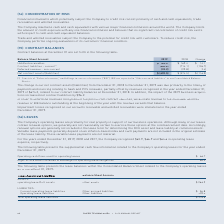According to Roper Technologies's financial document, How does the Company determine revenues recognized in the period from contract liabilities? we allocate revenue to the individual deferred revenue or BIE balance outstanding at the beginning of the year until the revenue exceeds that balance. The document states: "cognized in the period from contract liabilities, we allocate revenue to the individual deferred revenue or BIE balance outstanding at the beginning o..." Also, What were immaterial on the Company’s accounts receivable and unbilled receivables?  According to the financial document, Impairment losses. The relevant text states: "Impairment losses recognized on our accounts receivable and unbilled receivables were immaterial in the year ended De..." Also, How much were the net contract assets/(liabilities), in 2019? According to the financial document, $ (690.5). The relevant text states: "Net contract assets/(liabilities) $ (690.5) $ (574.5) $ (116.0)..." Also, can you calculate: What are the average unbilled receivables from 2018 to 2019? To answer this question, I need to perform calculations using the financial data. The calculation is: (183.5+169.4)/2 , which equals 176.45 (in millions). This is based on the information: "Unbilled receivables $ 183.5 $ 169.4 $ 14.1 Unbilled receivables $ 183.5 $ 169.4 $ 14.1..." The key data points involved are: 169.4, 183.5. Also, can you calculate: What is the ratio of unbilled receivables to revenues in year ended December 31,2019? Based on the calculation: 183.5/674.2 , the result is 0.27. This is based on the information: "Unbilled receivables $ 183.5 $ 169.4 $ 14.1 ecognized in the year ended December 31, 2019 of $674.2, related to our contract liability balances at December 31, 2018. In addition, the impact of the 20..." The key data points involved are: 183.5, 674.2. Also, can you calculate: What is the percentage change in current contract liabilities in 2019 compared to 2018? To answer this question, I need to perform calculations using the financial data. The calculation is: -126.7/-714.1 , which equals 17.74 (percentage). This is based on the information: "Contract liabilities - current (1) (840.8) (714.1) (126.7) ntract liabilities - current (1) (840.8) (714.1) (126.7)..." The key data points involved are: 126.7, 714.1. 